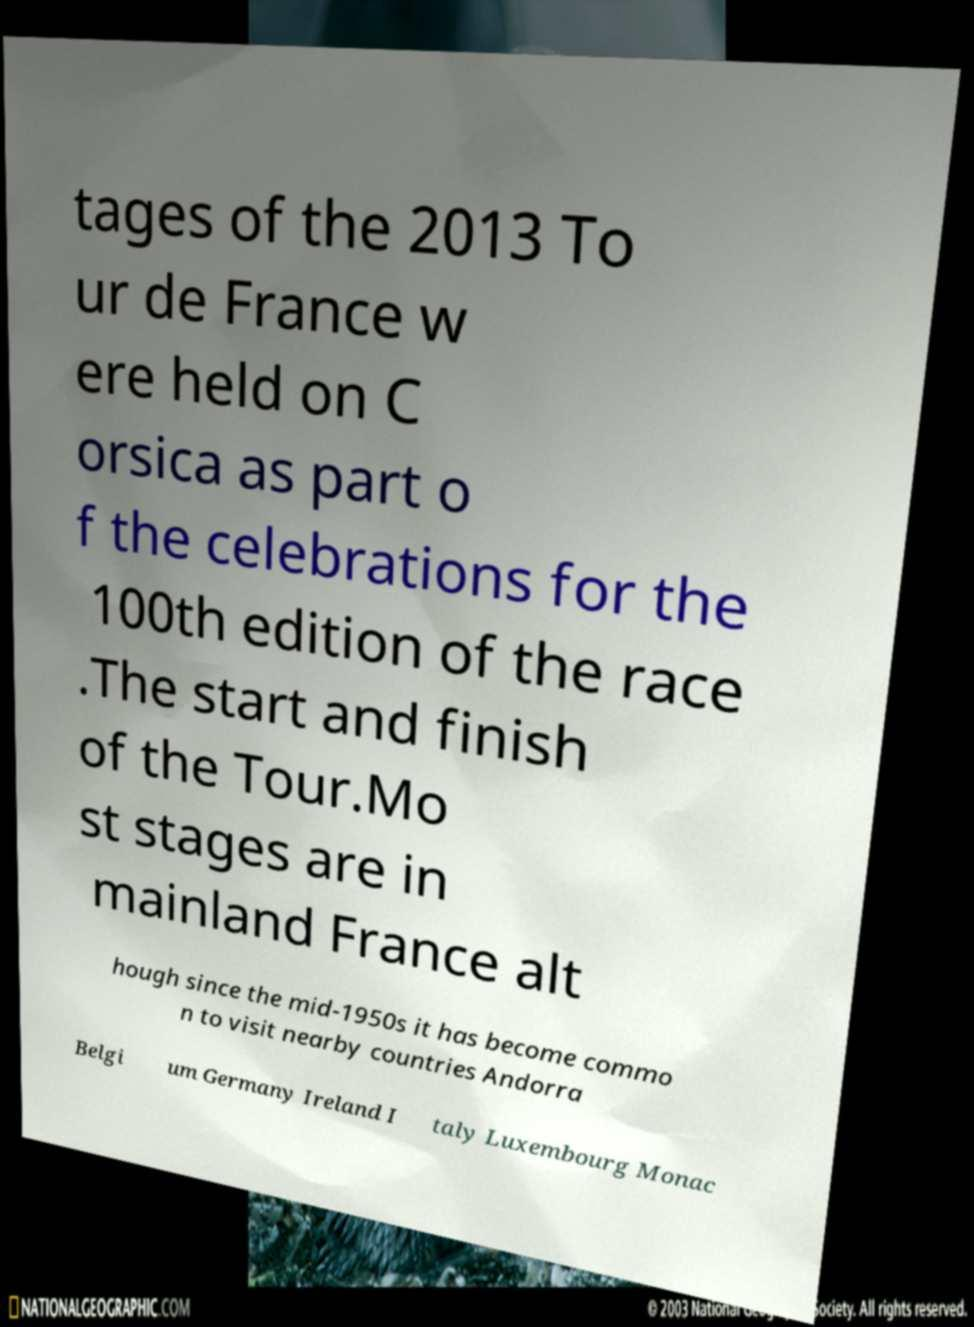Please read and relay the text visible in this image. What does it say? tages of the 2013 To ur de France w ere held on C orsica as part o f the celebrations for the 100th edition of the race .The start and finish of the Tour.Mo st stages are in mainland France alt hough since the mid-1950s it has become commo n to visit nearby countries Andorra Belgi um Germany Ireland I taly Luxembourg Monac 